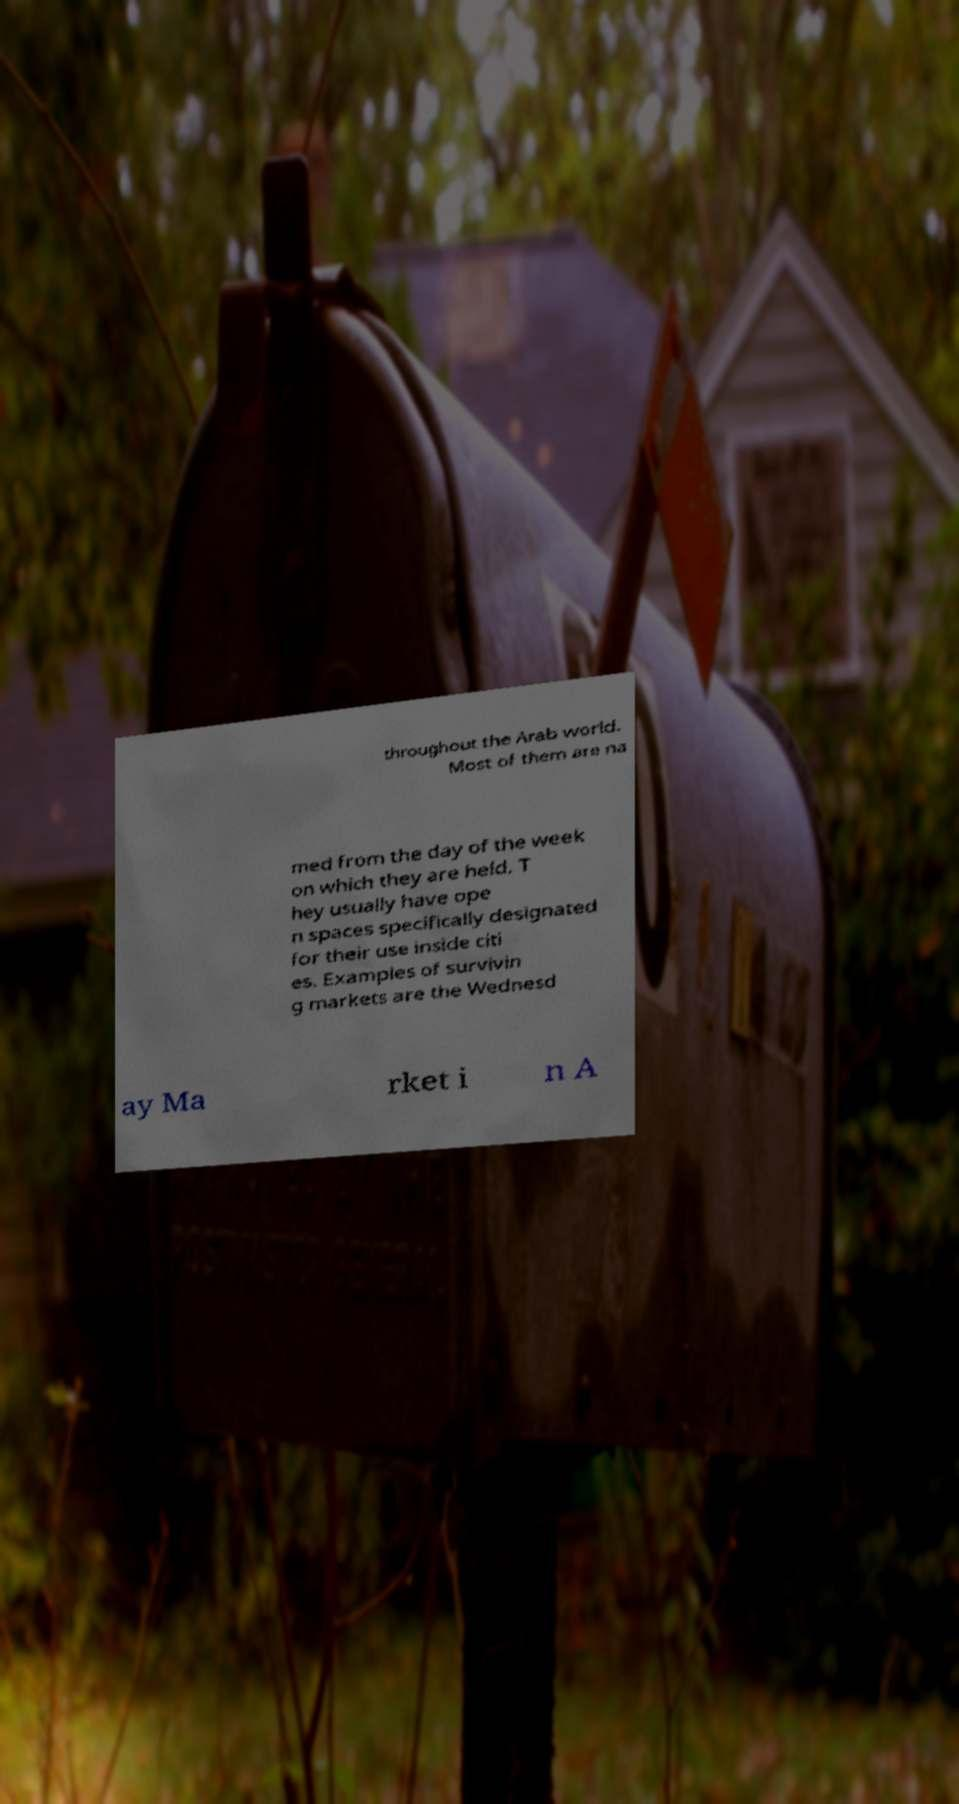Could you assist in decoding the text presented in this image and type it out clearly? throughout the Arab world. Most of them are na med from the day of the week on which they are held. T hey usually have ope n spaces specifically designated for their use inside citi es. Examples of survivin g markets are the Wednesd ay Ma rket i n A 